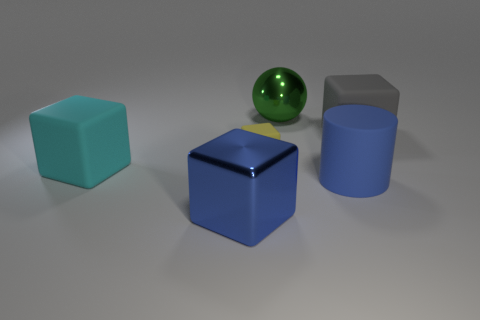Are there any other things that are the same size as the yellow block?
Give a very brief answer. No. There is a shiny thing that is in front of the big gray object; does it have the same color as the large cylinder?
Provide a short and direct response. Yes. How many blocks are big green metallic objects or metallic objects?
Give a very brief answer. 1. The large rubber object that is in front of the cyan block has what shape?
Make the answer very short. Cylinder. What is the color of the big metallic thing to the left of the metallic thing behind the big rubber thing behind the yellow object?
Your answer should be very brief. Blue. Does the small yellow cube have the same material as the gray cube?
Offer a very short reply. Yes. What number of purple things are either large things or big shiny things?
Your answer should be compact. 0. There is a blue block; how many cyan rubber cubes are to the left of it?
Your answer should be very brief. 1. Are there more big matte things than blocks?
Offer a terse response. No. The large shiny thing in front of the large rubber object that is to the right of the big blue cylinder is what shape?
Offer a very short reply. Cube. 